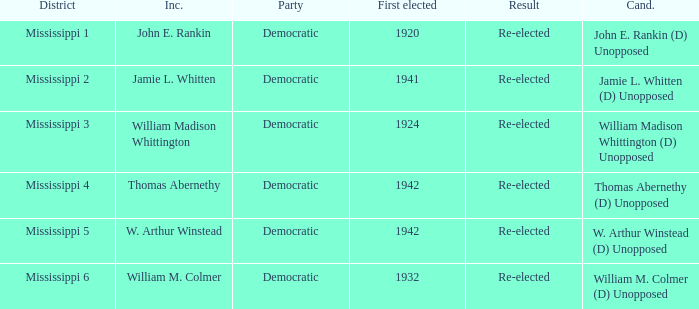What is the incumbent from 1941? Jamie L. Whitten. 